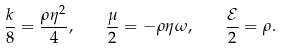<formula> <loc_0><loc_0><loc_500><loc_500>\frac { k } { 8 } = \frac { \rho \eta ^ { 2 } } { 4 } , \quad \frac { \mu } { 2 } = - \rho \eta \omega , \quad \frac { \mathcal { E } } { 2 } = \rho .</formula> 